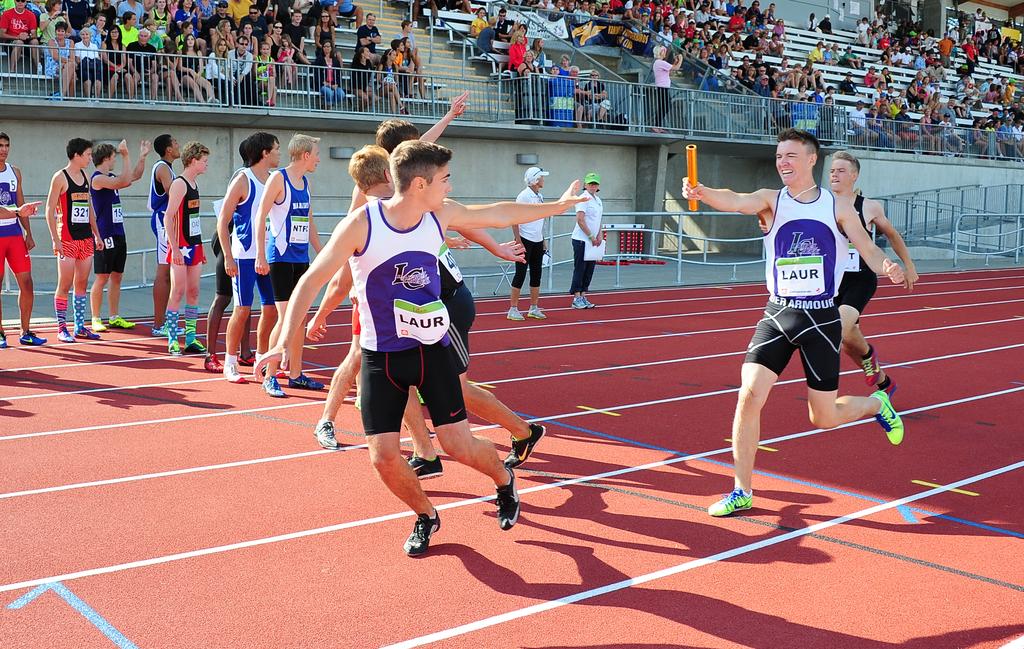What four letter word is displayed on each of the white and purple shirts?
Keep it short and to the point. Laur. What is the brand of the shorts the guy in green shoes is wearing?
Provide a succinct answer. Under armour. 